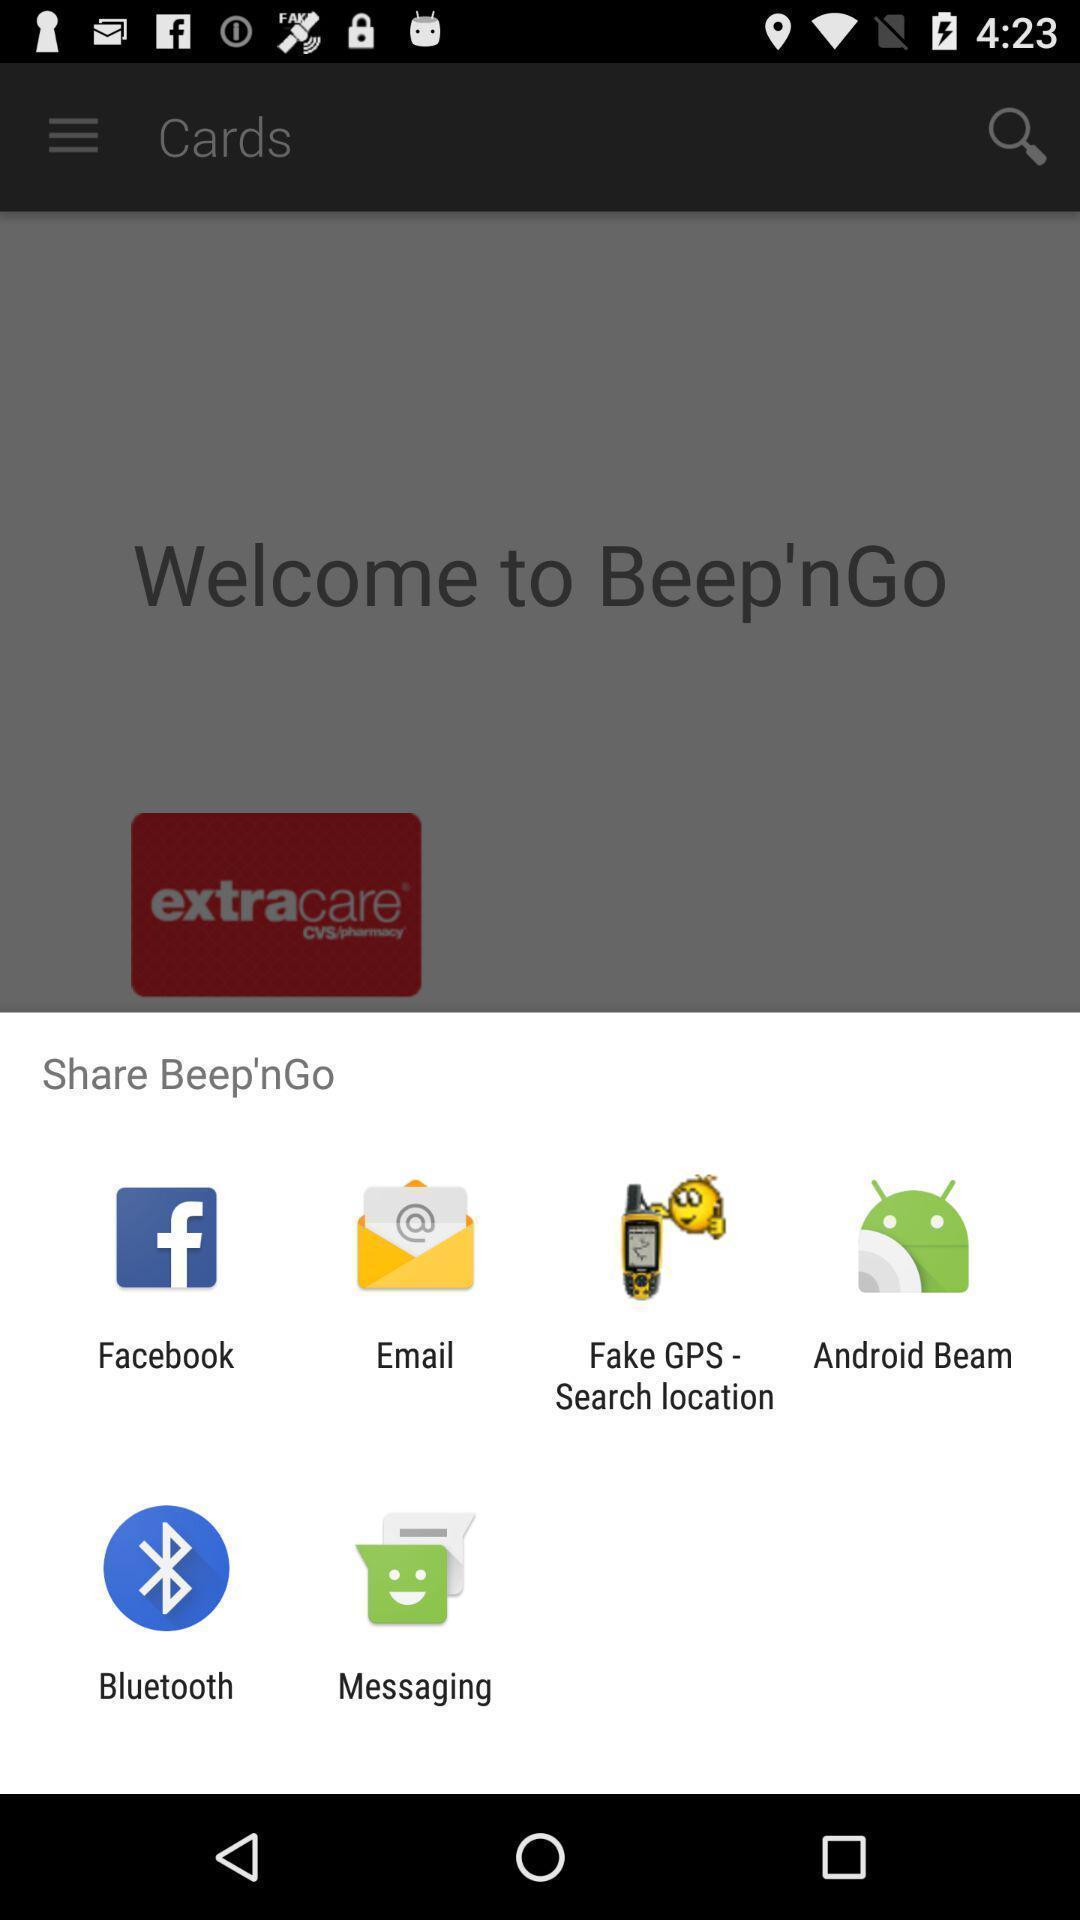Tell me what you see in this picture. Pop-up showing different sharing options. 